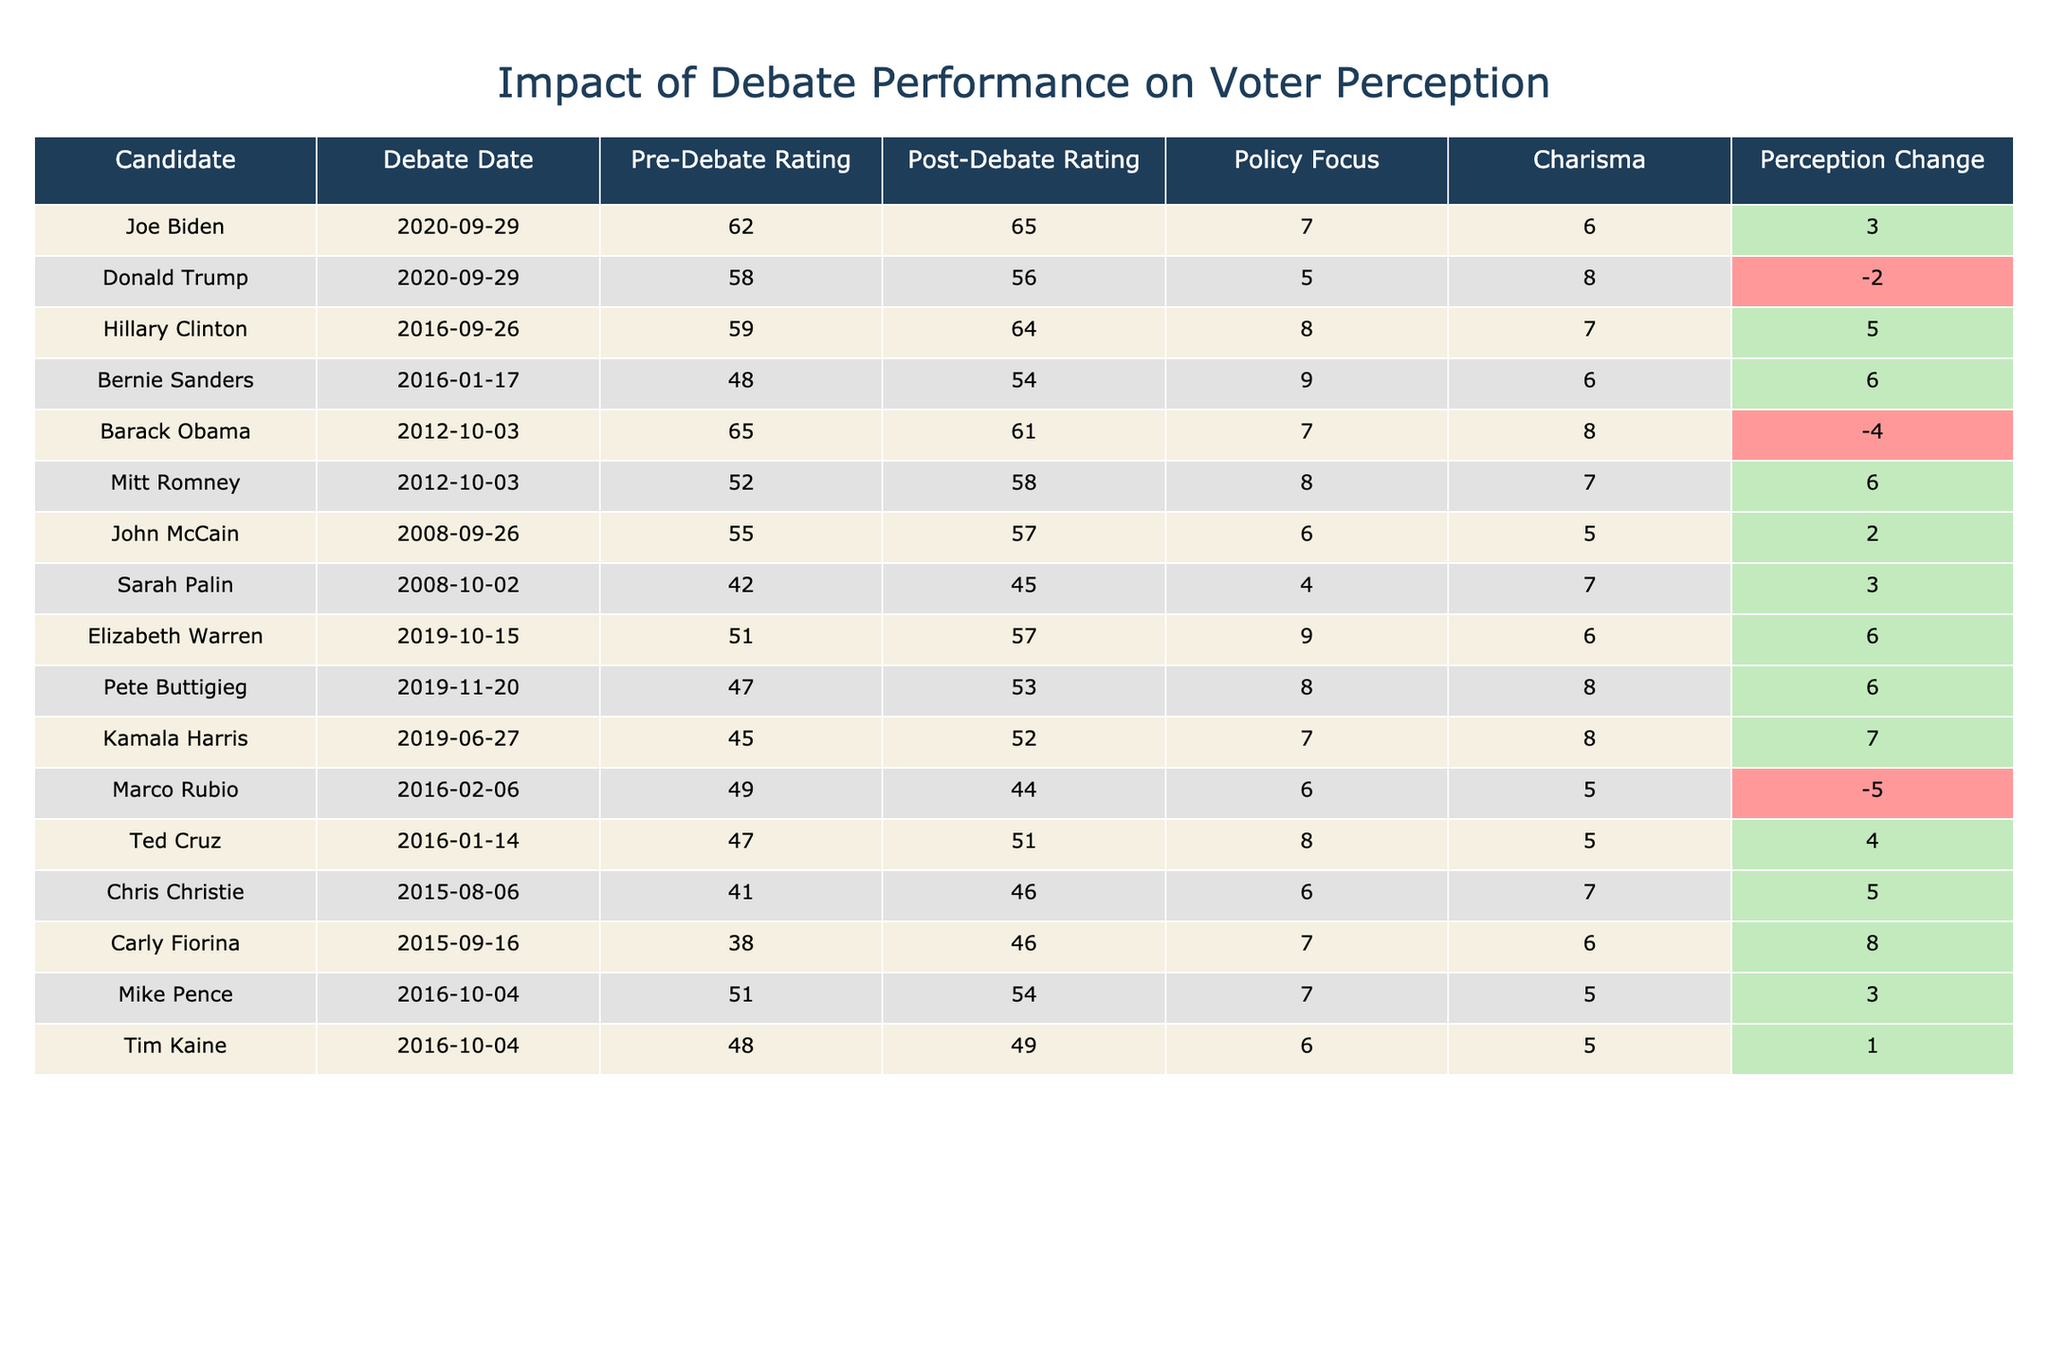What was the voter perception change for Joe Biden? The table shows that Joe Biden had a voter perception change of 3, which is listed in the 'Voter_Perception_Change' column.
Answer: 3 Which candidate had the highest post-debate qualification rating? By comparing the 'Post-Debate_Qualification_Rating' values, Hillary Clinton has the highest rating of 64.
Answer: 64 What was the difference between pre-debate and post-debate qualification ratings for Bernie Sanders? Bernie's pre-debate rating was 48 and the post-debate rating was 54, so the difference is 54 - 48 = 6.
Answer: 6 Did Marco Rubio experience a positive change in voter perception after the debate? Marco Rubio's voter perception change is -5, which indicates a negative change.
Answer: No Which candidate had the lowest charisma score? In the 'Charisma_Score' column, Carly Fiorina had the lowest score of 6.
Answer: 6 What is the average post-debate qualification rating for all candidates in 2016? The 2016 candidates are Hillary Clinton, Bernie Sanders, Marco Rubio, and Ted Cruz. Their post-debate ratings are 64, 54, 44, and 51, respectively. The average is (64 + 54 + 44 + 51) / 4 = 53.25.
Answer: 53.25 Which candidates had a voter perception change greater than 5? The candidates with a voter perception change greater than 5 are Hillary Clinton (5), Bernie Sanders (6), Elizabeth Warren (6), Pete Buttigieg (6), and Carly Fiorina (8).
Answer: Hillary Clinton, Bernie Sanders, Elizabeth Warren, Pete Buttigieg, Carly Fiorina Is there a trend indicating that candidates with higher policy focus scores tend to have a higher voter perception change? Looking at the 'Policy_Focus_Score' and 'Voter_Perception_Change', we find mixed results. For example, Joe Biden (7) had a positive change (3), while Donald Trump (5) had a negative change (-2), suggesting no consistent trend.
Answer: No clear trend How does Obama's post-debate qualification rating compare to his pre-debate rating? Barack Obama's pre-debate rating was 65 and his post-debate rating was 61. The comparison shows a decrease of 4.
Answer: Decrease of 4 Which candidate had the most significant negative shift in voter perception? Donald Trump had the most significant negative shift in voter perception with a change of -2.
Answer: -2 How many candidates had a charisma score of 8 or higher? The candidates with a charisma score of 8 or higher are Donald Trump, Barack Obama, Kamala Harris, and Pete Buttigieg, totaling 4 candidates.
Answer: 4 